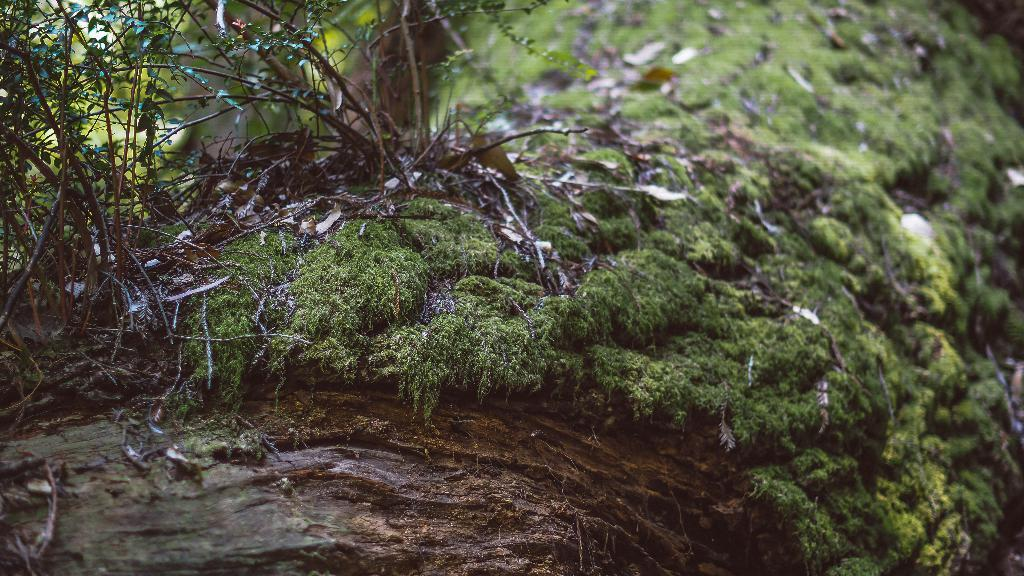What is the main subject of the image? The main subject of the image is a tree trunk. What can be seen on the tree trunk? There is grass, leaves, and a plant on the tree trunk. What is the condition of the background in the image? The background of the image is blurry and green in color. Where is the market located in the image? There is no market present in the image; it features a tree trunk with grass, leaves, and a plant. What type of light source is illuminating the tree trunk in the image? There is no specific light source mentioned or visible in the image; it is a photograph of a tree trunk with grass, leaves, and a plant. 